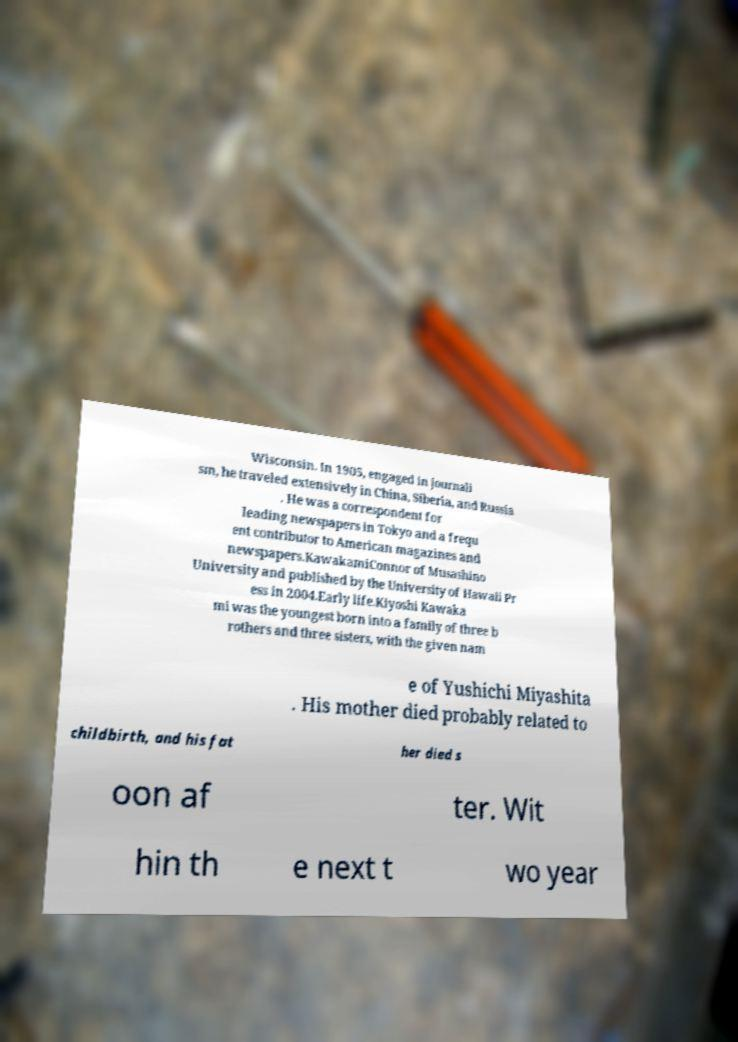There's text embedded in this image that I need extracted. Can you transcribe it verbatim? Wisconsin. In 1905, engaged in journali sm, he traveled extensively in China, Siberia, and Russia . He was a correspondent for leading newspapers in Tokyo and a frequ ent contributor to American magazines and newspapers.KawakamiConnor of Musashino University and published by the University of Hawaii Pr ess in 2004.Early life.Kiyoshi Kawaka mi was the youngest born into a family of three b rothers and three sisters, with the given nam e of Yushichi Miyashita . His mother died probably related to childbirth, and his fat her died s oon af ter. Wit hin th e next t wo year 